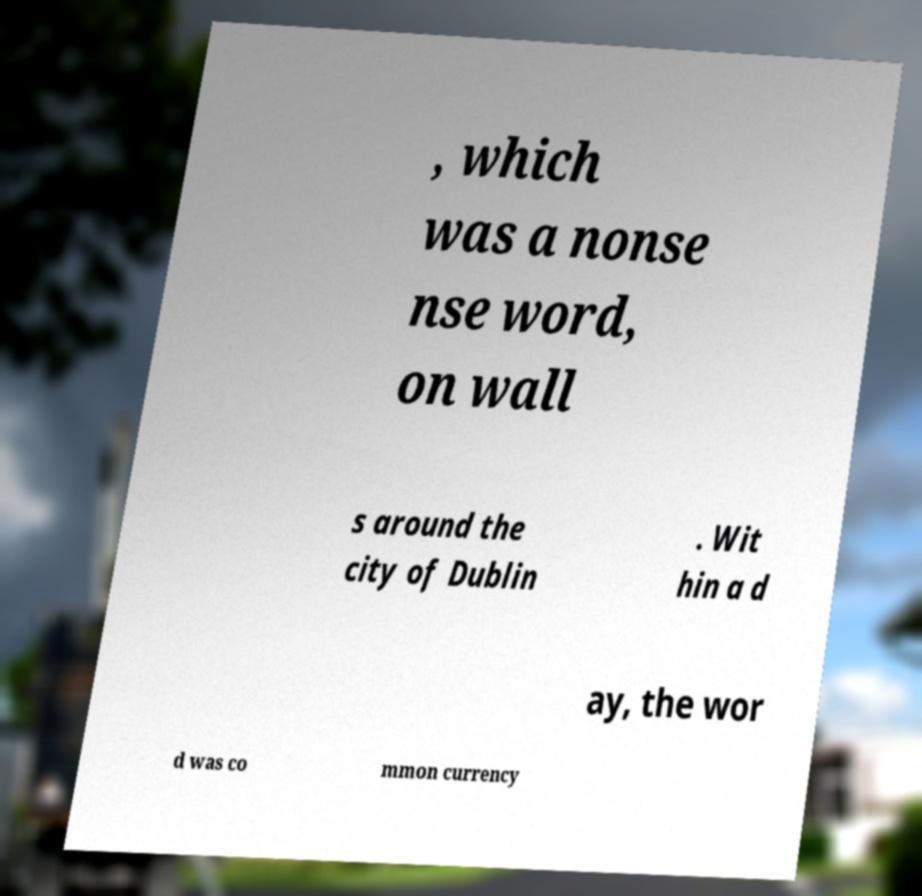Can you accurately transcribe the text from the provided image for me? , which was a nonse nse word, on wall s around the city of Dublin . Wit hin a d ay, the wor d was co mmon currency 